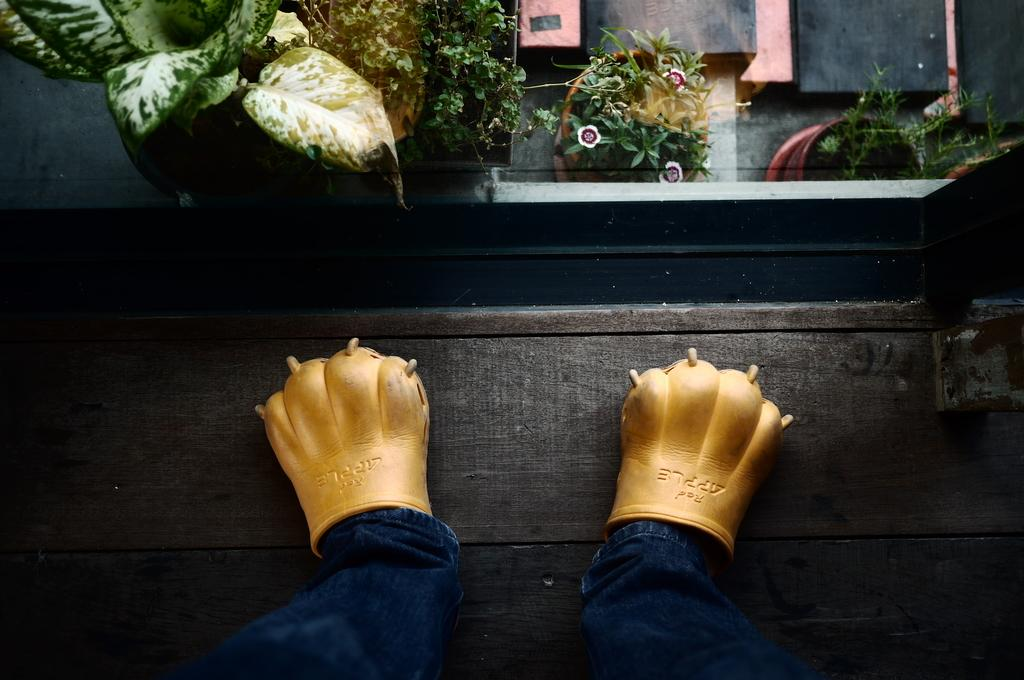What type of clothing item is in the image? There is a pair of jeans in the image. What other clothing item is in the image? There are gloves in the image. Where are the jeans and gloves located? The jeans and gloves are on a wooden path. What can be seen behind the gloves in the image? There are pots with plants behind the gloves. How many cats are sitting on the pair of jeans in the image? There are no cats present in the image; it only features a pair of jeans and gloves on a wooden path with pots and plants behind the gloves. 